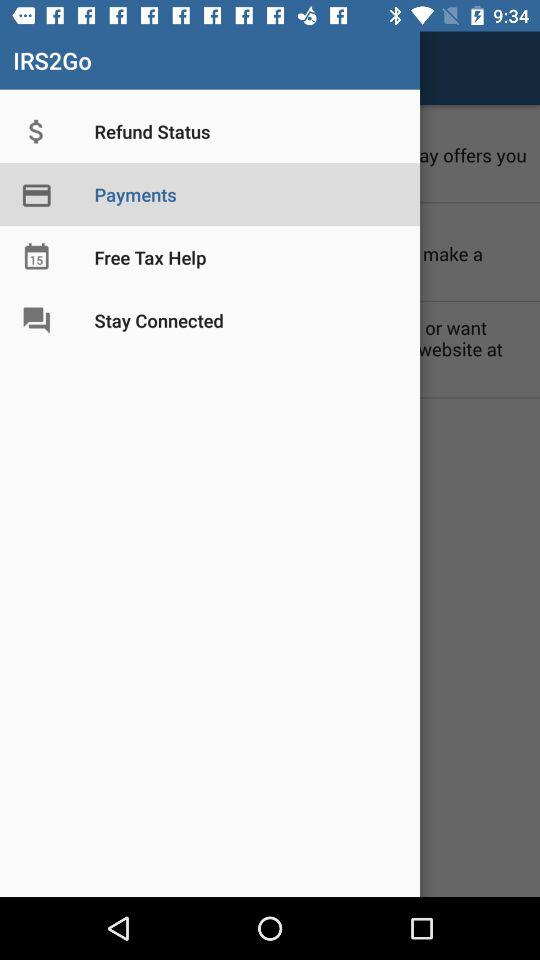What is the selected item in "IRS2Go"? The selected item is "Payments". 